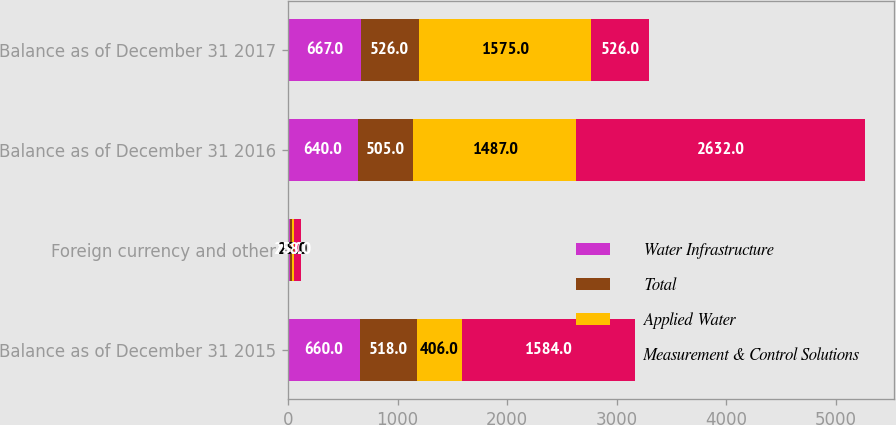Convert chart. <chart><loc_0><loc_0><loc_500><loc_500><stacked_bar_chart><ecel><fcel>Balance as of December 31 2015<fcel>Foreign currency and other<fcel>Balance as of December 31 2016<fcel>Balance as of December 31 2017<nl><fcel>Water Infrastructure<fcel>660<fcel>20<fcel>640<fcel>667<nl><fcel>Total<fcel>518<fcel>13<fcel>505<fcel>526<nl><fcel>Applied Water<fcel>406<fcel>25<fcel>1487<fcel>1575<nl><fcel>Measurement & Control Solutions<fcel>1584<fcel>58<fcel>2632<fcel>526<nl></chart> 